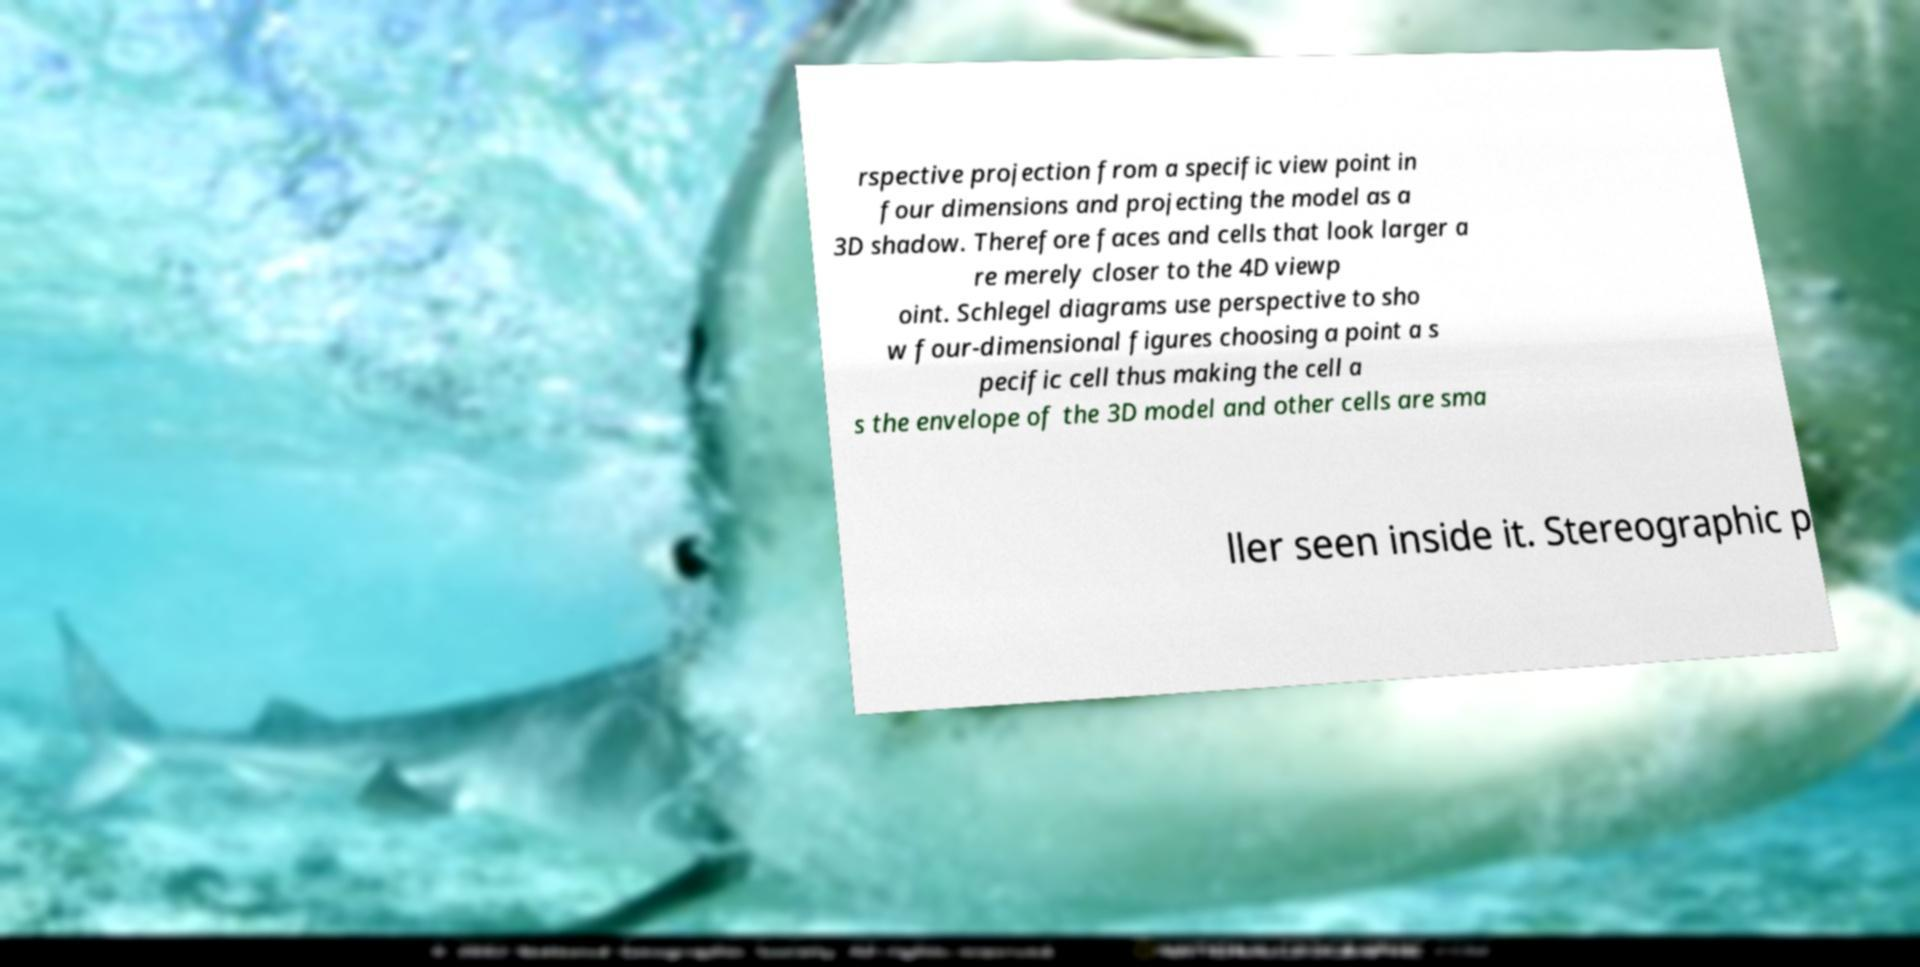Can you accurately transcribe the text from the provided image for me? rspective projection from a specific view point in four dimensions and projecting the model as a 3D shadow. Therefore faces and cells that look larger a re merely closer to the 4D viewp oint. Schlegel diagrams use perspective to sho w four-dimensional figures choosing a point a s pecific cell thus making the cell a s the envelope of the 3D model and other cells are sma ller seen inside it. Stereographic p 